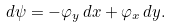Convert formula to latex. <formula><loc_0><loc_0><loc_500><loc_500>d \psi = - \varphi _ { y } \, d x + \varphi _ { x } \, d y .</formula> 